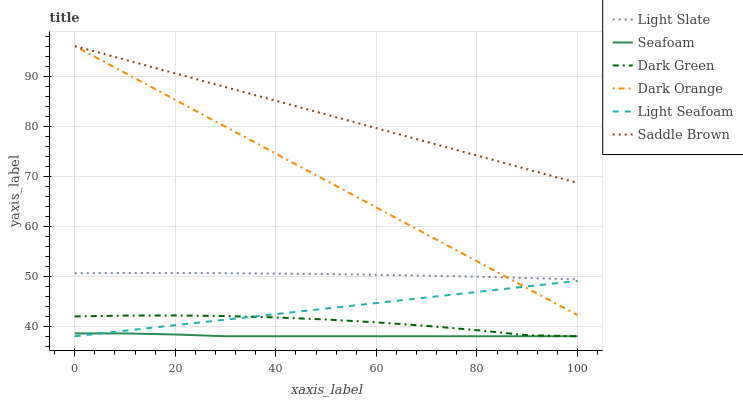Does Light Slate have the minimum area under the curve?
Answer yes or no. No. Does Light Slate have the maximum area under the curve?
Answer yes or no. No. Is Light Slate the smoothest?
Answer yes or no. No. Is Light Slate the roughest?
Answer yes or no. No. Does Light Slate have the lowest value?
Answer yes or no. No. Does Light Slate have the highest value?
Answer yes or no. No. Is Light Seafoam less than Saddle Brown?
Answer yes or no. Yes. Is Dark Orange greater than Seafoam?
Answer yes or no. Yes. Does Light Seafoam intersect Saddle Brown?
Answer yes or no. No. 